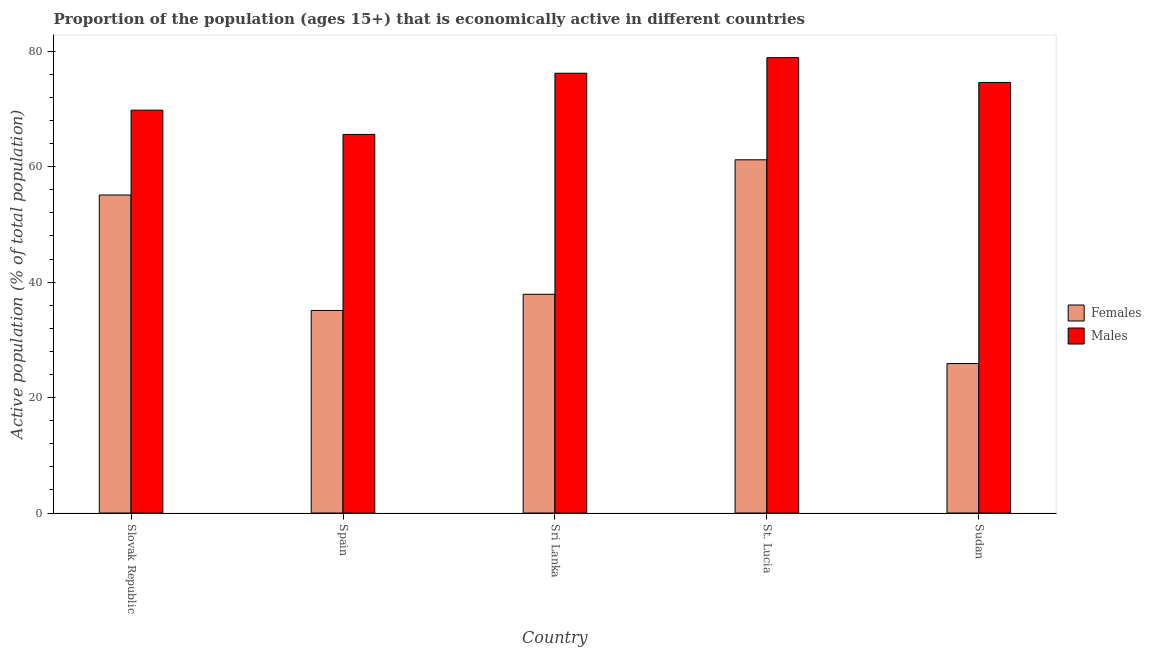Are the number of bars per tick equal to the number of legend labels?
Your answer should be compact. Yes. How many bars are there on the 2nd tick from the left?
Provide a succinct answer. 2. What is the label of the 1st group of bars from the left?
Your answer should be very brief. Slovak Republic. In how many cases, is the number of bars for a given country not equal to the number of legend labels?
Provide a short and direct response. 0. What is the percentage of economically active male population in Sri Lanka?
Offer a terse response. 76.2. Across all countries, what is the maximum percentage of economically active female population?
Ensure brevity in your answer.  61.2. Across all countries, what is the minimum percentage of economically active male population?
Your response must be concise. 65.6. In which country was the percentage of economically active female population maximum?
Provide a short and direct response. St. Lucia. In which country was the percentage of economically active male population minimum?
Your answer should be compact. Spain. What is the total percentage of economically active male population in the graph?
Your answer should be compact. 365.1. What is the difference between the percentage of economically active female population in Slovak Republic and that in Sri Lanka?
Keep it short and to the point. 17.2. What is the difference between the percentage of economically active female population in Sri Lanka and the percentage of economically active male population in Spain?
Provide a short and direct response. -27.7. What is the average percentage of economically active female population per country?
Your answer should be very brief. 43.04. What is the difference between the percentage of economically active female population and percentage of economically active male population in Spain?
Offer a very short reply. -30.5. What is the ratio of the percentage of economically active male population in Sri Lanka to that in Sudan?
Keep it short and to the point. 1.02. Is the difference between the percentage of economically active female population in Sri Lanka and Sudan greater than the difference between the percentage of economically active male population in Sri Lanka and Sudan?
Ensure brevity in your answer.  Yes. What is the difference between the highest and the second highest percentage of economically active female population?
Offer a very short reply. 6.1. What is the difference between the highest and the lowest percentage of economically active female population?
Provide a short and direct response. 35.3. In how many countries, is the percentage of economically active female population greater than the average percentage of economically active female population taken over all countries?
Your response must be concise. 2. What does the 2nd bar from the left in Sudan represents?
Make the answer very short. Males. What does the 2nd bar from the right in Spain represents?
Give a very brief answer. Females. How many bars are there?
Give a very brief answer. 10. Are all the bars in the graph horizontal?
Provide a short and direct response. No. Are the values on the major ticks of Y-axis written in scientific E-notation?
Your answer should be compact. No. Does the graph contain any zero values?
Give a very brief answer. No. How many legend labels are there?
Your answer should be compact. 2. How are the legend labels stacked?
Your response must be concise. Vertical. What is the title of the graph?
Offer a terse response. Proportion of the population (ages 15+) that is economically active in different countries. Does "State government" appear as one of the legend labels in the graph?
Provide a short and direct response. No. What is the label or title of the Y-axis?
Your response must be concise. Active population (% of total population). What is the Active population (% of total population) of Females in Slovak Republic?
Ensure brevity in your answer.  55.1. What is the Active population (% of total population) of Males in Slovak Republic?
Ensure brevity in your answer.  69.8. What is the Active population (% of total population) of Females in Spain?
Your answer should be compact. 35.1. What is the Active population (% of total population) in Males in Spain?
Your answer should be compact. 65.6. What is the Active population (% of total population) in Females in Sri Lanka?
Provide a succinct answer. 37.9. What is the Active population (% of total population) in Males in Sri Lanka?
Give a very brief answer. 76.2. What is the Active population (% of total population) in Females in St. Lucia?
Ensure brevity in your answer.  61.2. What is the Active population (% of total population) of Males in St. Lucia?
Your response must be concise. 78.9. What is the Active population (% of total population) in Females in Sudan?
Your answer should be compact. 25.9. What is the Active population (% of total population) in Males in Sudan?
Your answer should be very brief. 74.6. Across all countries, what is the maximum Active population (% of total population) of Females?
Keep it short and to the point. 61.2. Across all countries, what is the maximum Active population (% of total population) of Males?
Make the answer very short. 78.9. Across all countries, what is the minimum Active population (% of total population) of Females?
Ensure brevity in your answer.  25.9. Across all countries, what is the minimum Active population (% of total population) in Males?
Keep it short and to the point. 65.6. What is the total Active population (% of total population) of Females in the graph?
Your response must be concise. 215.2. What is the total Active population (% of total population) of Males in the graph?
Give a very brief answer. 365.1. What is the difference between the Active population (% of total population) in Females in Slovak Republic and that in Sri Lanka?
Your answer should be very brief. 17.2. What is the difference between the Active population (% of total population) in Males in Slovak Republic and that in Sri Lanka?
Offer a terse response. -6.4. What is the difference between the Active population (% of total population) of Males in Slovak Republic and that in St. Lucia?
Your response must be concise. -9.1. What is the difference between the Active population (% of total population) of Females in Slovak Republic and that in Sudan?
Keep it short and to the point. 29.2. What is the difference between the Active population (% of total population) in Males in Slovak Republic and that in Sudan?
Provide a short and direct response. -4.8. What is the difference between the Active population (% of total population) of Females in Spain and that in St. Lucia?
Ensure brevity in your answer.  -26.1. What is the difference between the Active population (% of total population) in Males in Spain and that in Sudan?
Provide a short and direct response. -9. What is the difference between the Active population (% of total population) in Females in Sri Lanka and that in St. Lucia?
Offer a very short reply. -23.3. What is the difference between the Active population (% of total population) of Males in Sri Lanka and that in St. Lucia?
Offer a terse response. -2.7. What is the difference between the Active population (% of total population) in Males in Sri Lanka and that in Sudan?
Keep it short and to the point. 1.6. What is the difference between the Active population (% of total population) in Females in St. Lucia and that in Sudan?
Provide a short and direct response. 35.3. What is the difference between the Active population (% of total population) in Males in St. Lucia and that in Sudan?
Your response must be concise. 4.3. What is the difference between the Active population (% of total population) of Females in Slovak Republic and the Active population (% of total population) of Males in Spain?
Keep it short and to the point. -10.5. What is the difference between the Active population (% of total population) of Females in Slovak Republic and the Active population (% of total population) of Males in Sri Lanka?
Keep it short and to the point. -21.1. What is the difference between the Active population (% of total population) of Females in Slovak Republic and the Active population (% of total population) of Males in St. Lucia?
Keep it short and to the point. -23.8. What is the difference between the Active population (% of total population) of Females in Slovak Republic and the Active population (% of total population) of Males in Sudan?
Ensure brevity in your answer.  -19.5. What is the difference between the Active population (% of total population) of Females in Spain and the Active population (% of total population) of Males in Sri Lanka?
Keep it short and to the point. -41.1. What is the difference between the Active population (% of total population) in Females in Spain and the Active population (% of total population) in Males in St. Lucia?
Offer a very short reply. -43.8. What is the difference between the Active population (% of total population) in Females in Spain and the Active population (% of total population) in Males in Sudan?
Offer a terse response. -39.5. What is the difference between the Active population (% of total population) in Females in Sri Lanka and the Active population (% of total population) in Males in St. Lucia?
Offer a terse response. -41. What is the difference between the Active population (% of total population) in Females in Sri Lanka and the Active population (% of total population) in Males in Sudan?
Give a very brief answer. -36.7. What is the difference between the Active population (% of total population) in Females in St. Lucia and the Active population (% of total population) in Males in Sudan?
Your response must be concise. -13.4. What is the average Active population (% of total population) in Females per country?
Give a very brief answer. 43.04. What is the average Active population (% of total population) in Males per country?
Offer a very short reply. 73.02. What is the difference between the Active population (% of total population) of Females and Active population (% of total population) of Males in Slovak Republic?
Provide a succinct answer. -14.7. What is the difference between the Active population (% of total population) in Females and Active population (% of total population) in Males in Spain?
Provide a short and direct response. -30.5. What is the difference between the Active population (% of total population) of Females and Active population (% of total population) of Males in Sri Lanka?
Make the answer very short. -38.3. What is the difference between the Active population (% of total population) of Females and Active population (% of total population) of Males in St. Lucia?
Offer a terse response. -17.7. What is the difference between the Active population (% of total population) in Females and Active population (% of total population) in Males in Sudan?
Your answer should be compact. -48.7. What is the ratio of the Active population (% of total population) in Females in Slovak Republic to that in Spain?
Your answer should be very brief. 1.57. What is the ratio of the Active population (% of total population) of Males in Slovak Republic to that in Spain?
Ensure brevity in your answer.  1.06. What is the ratio of the Active population (% of total population) of Females in Slovak Republic to that in Sri Lanka?
Provide a succinct answer. 1.45. What is the ratio of the Active population (% of total population) of Males in Slovak Republic to that in Sri Lanka?
Offer a very short reply. 0.92. What is the ratio of the Active population (% of total population) in Females in Slovak Republic to that in St. Lucia?
Offer a terse response. 0.9. What is the ratio of the Active population (% of total population) in Males in Slovak Republic to that in St. Lucia?
Ensure brevity in your answer.  0.88. What is the ratio of the Active population (% of total population) of Females in Slovak Republic to that in Sudan?
Provide a succinct answer. 2.13. What is the ratio of the Active population (% of total population) in Males in Slovak Republic to that in Sudan?
Provide a short and direct response. 0.94. What is the ratio of the Active population (% of total population) in Females in Spain to that in Sri Lanka?
Ensure brevity in your answer.  0.93. What is the ratio of the Active population (% of total population) in Males in Spain to that in Sri Lanka?
Give a very brief answer. 0.86. What is the ratio of the Active population (% of total population) of Females in Spain to that in St. Lucia?
Make the answer very short. 0.57. What is the ratio of the Active population (% of total population) in Males in Spain to that in St. Lucia?
Offer a terse response. 0.83. What is the ratio of the Active population (% of total population) in Females in Spain to that in Sudan?
Offer a very short reply. 1.36. What is the ratio of the Active population (% of total population) in Males in Spain to that in Sudan?
Keep it short and to the point. 0.88. What is the ratio of the Active population (% of total population) of Females in Sri Lanka to that in St. Lucia?
Your answer should be compact. 0.62. What is the ratio of the Active population (% of total population) of Males in Sri Lanka to that in St. Lucia?
Offer a terse response. 0.97. What is the ratio of the Active population (% of total population) in Females in Sri Lanka to that in Sudan?
Keep it short and to the point. 1.46. What is the ratio of the Active population (% of total population) in Males in Sri Lanka to that in Sudan?
Provide a short and direct response. 1.02. What is the ratio of the Active population (% of total population) in Females in St. Lucia to that in Sudan?
Keep it short and to the point. 2.36. What is the ratio of the Active population (% of total population) in Males in St. Lucia to that in Sudan?
Provide a short and direct response. 1.06. What is the difference between the highest and the second highest Active population (% of total population) in Females?
Offer a very short reply. 6.1. What is the difference between the highest and the lowest Active population (% of total population) of Females?
Provide a succinct answer. 35.3. What is the difference between the highest and the lowest Active population (% of total population) in Males?
Provide a succinct answer. 13.3. 